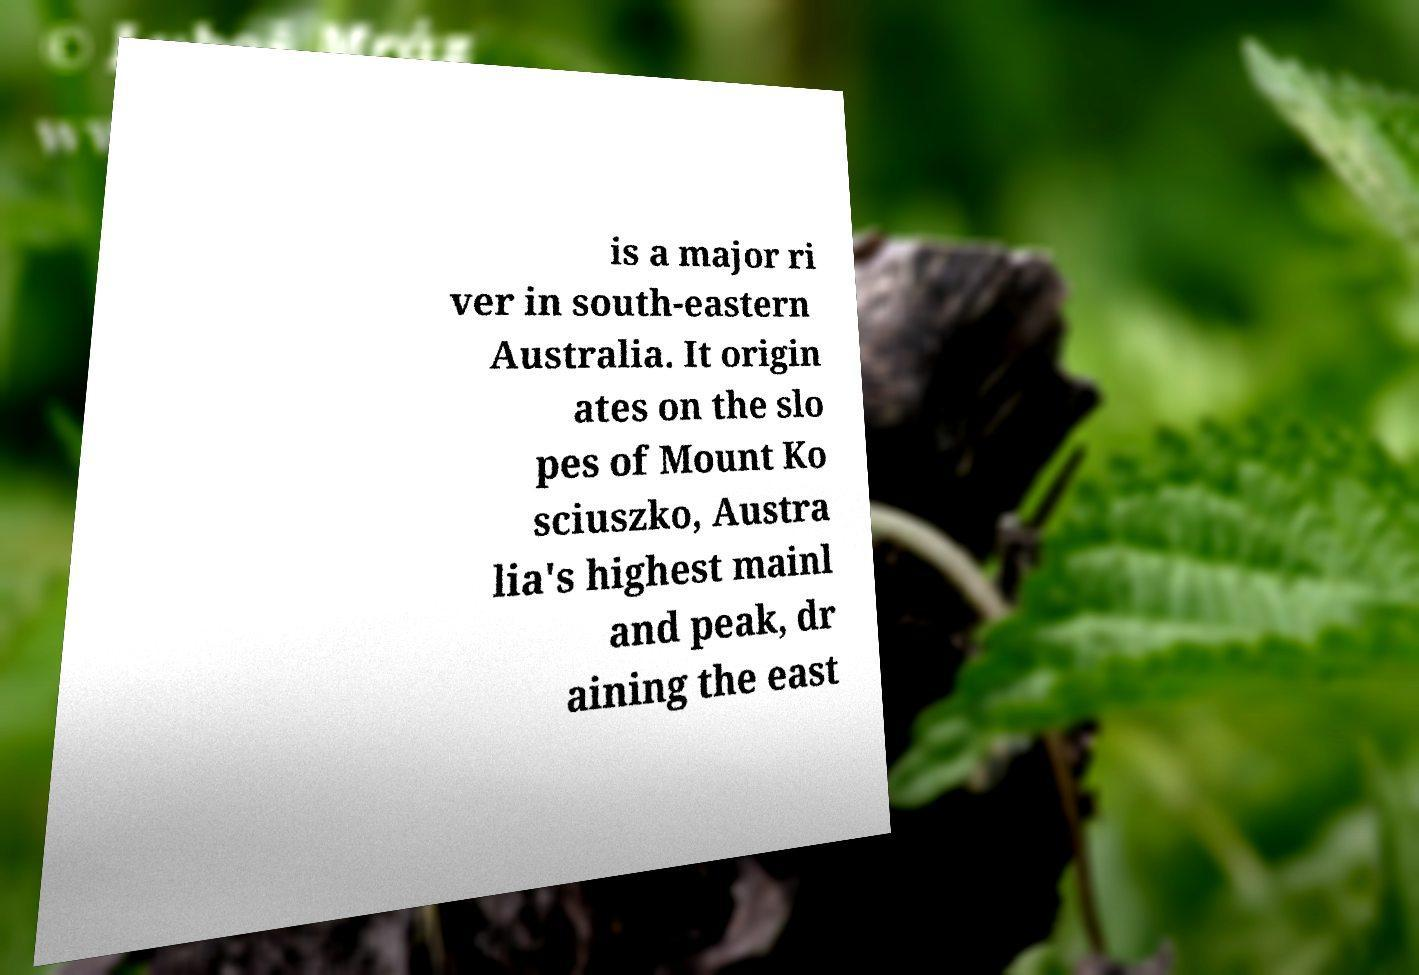Please identify and transcribe the text found in this image. is a major ri ver in south-eastern Australia. It origin ates on the slo pes of Mount Ko sciuszko, Austra lia's highest mainl and peak, dr aining the east 